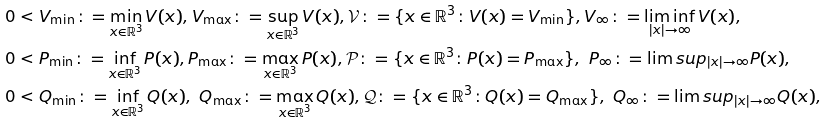Convert formula to latex. <formula><loc_0><loc_0><loc_500><loc_500>& 0 < V _ { \min } \colon = \min _ { x \in \mathbb { R } ^ { 3 } } V ( x ) , V _ { \max } \colon = \sup _ { x \in \mathbb { R } ^ { 3 } } V ( x ) , \mathcal { V } \colon = \{ x \in \mathbb { R } ^ { 3 } \colon V ( x ) = V _ { \min } \} , V _ { \infty } \colon = \liminf _ { | x | \rightarrow \infty } V ( x ) , \\ & 0 < P _ { \min } \colon = \inf _ { x \in \mathbb { R } ^ { 3 } } P ( x ) , P _ { \max } \colon = \max _ { x \in \mathbb { R } ^ { 3 } } P ( x ) , \mathcal { P } \colon = \{ x \in \mathbb { R } ^ { 3 } \colon P ( x ) = P _ { \max } \} , \ P _ { \infty } \colon = \lim s u p _ { | x | \rightarrow \infty } P ( x ) , \\ & 0 < Q _ { \min } \colon = \inf _ { x \in \mathbb { R } ^ { 3 } } Q ( x ) , \ Q _ { \max } \colon = \max _ { x \in \mathbb { R } ^ { 3 } } Q ( x ) , \mathcal { Q } \colon = \{ x \in \mathbb { R } ^ { 3 } \colon Q ( x ) = Q _ { \max } \} , \ Q _ { \infty } \colon = \lim s u p _ { | x | \rightarrow \infty } Q ( x ) , \\</formula> 